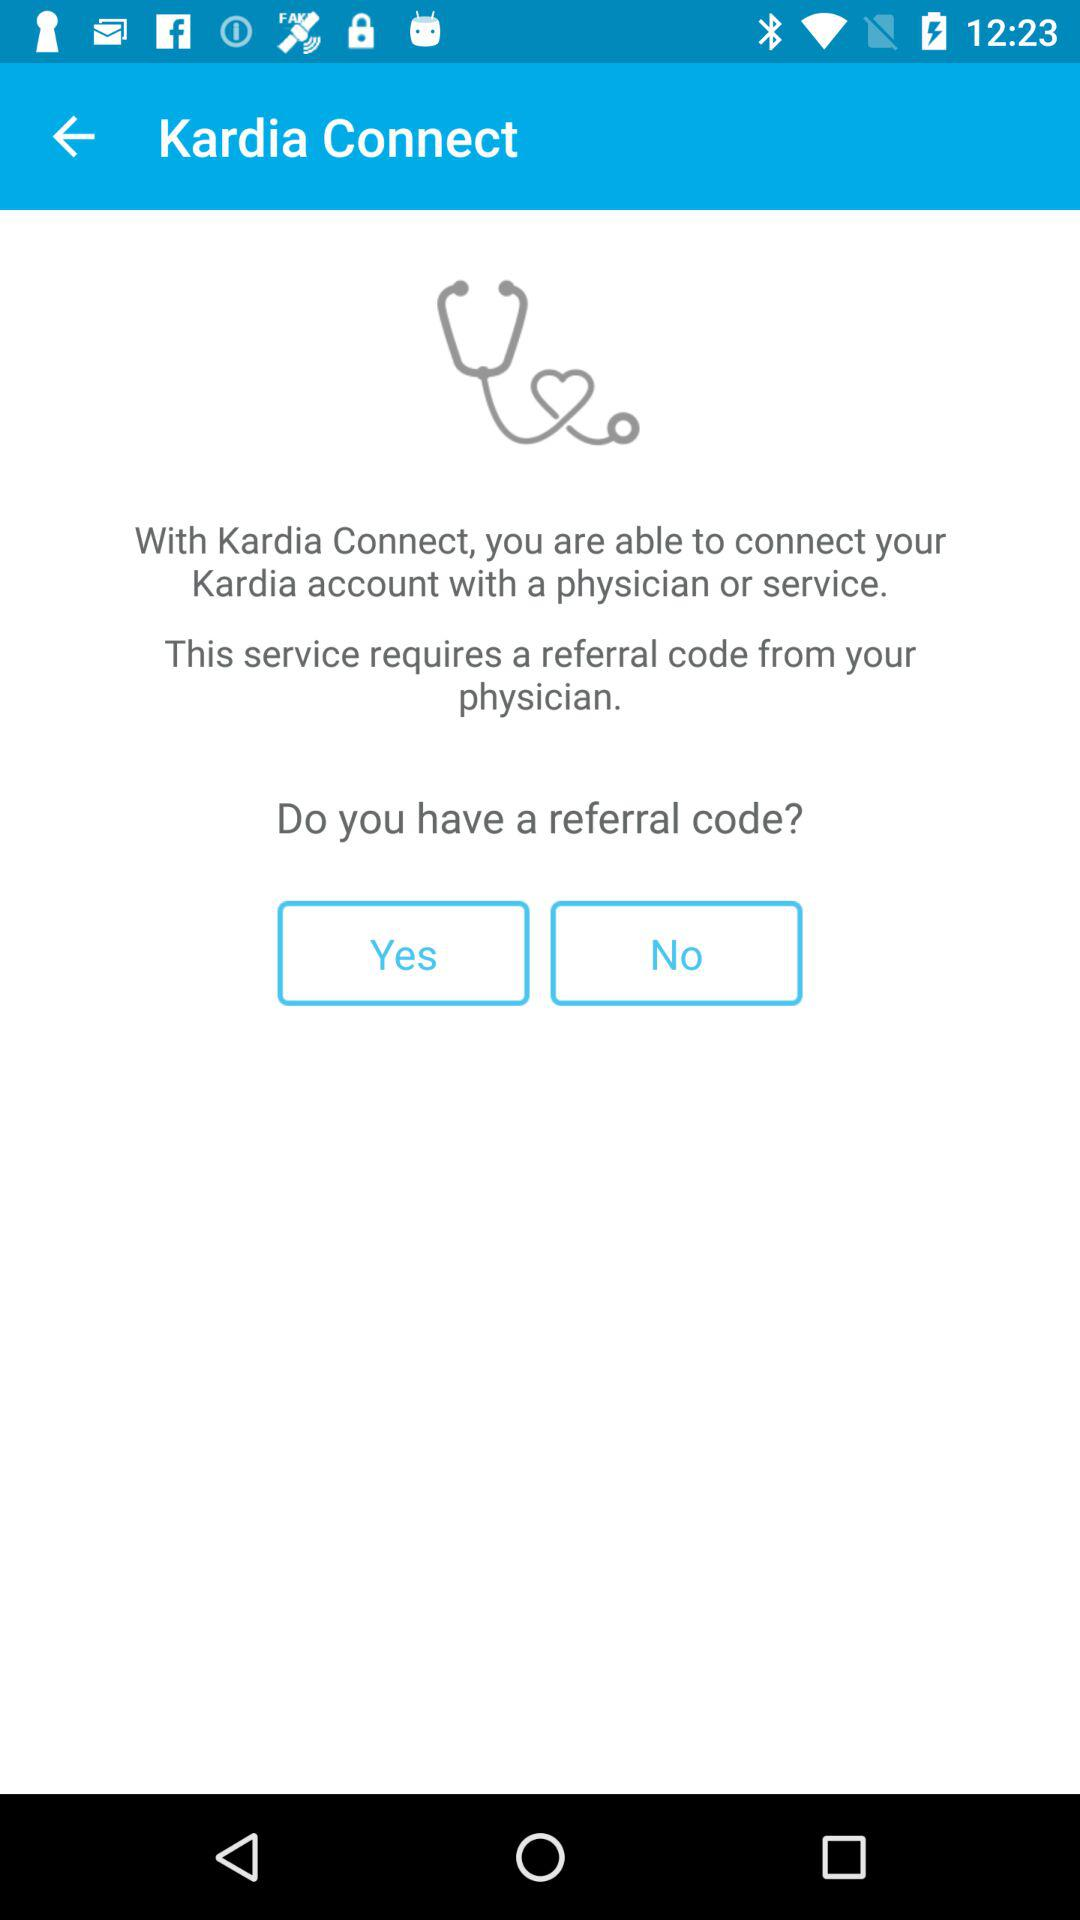What is the application name? The application name is "Kardia Connect". 